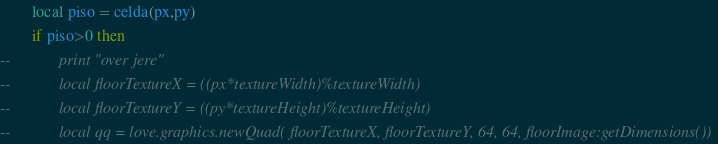Convert code to text. <code><loc_0><loc_0><loc_500><loc_500><_Lua_>		local piso = celda(px,py)
		if piso>0 then
--            print "over jere"
--            local floorTextureX = ((px*textureWidth)%textureWidth)
--            local floorTextureY = ((py*textureHeight)%textureHeight)
--            local qq = love.graphics.newQuad( floorTextureX, floorTextureY, 64, 64, floorImage:getDimensions())</code> 